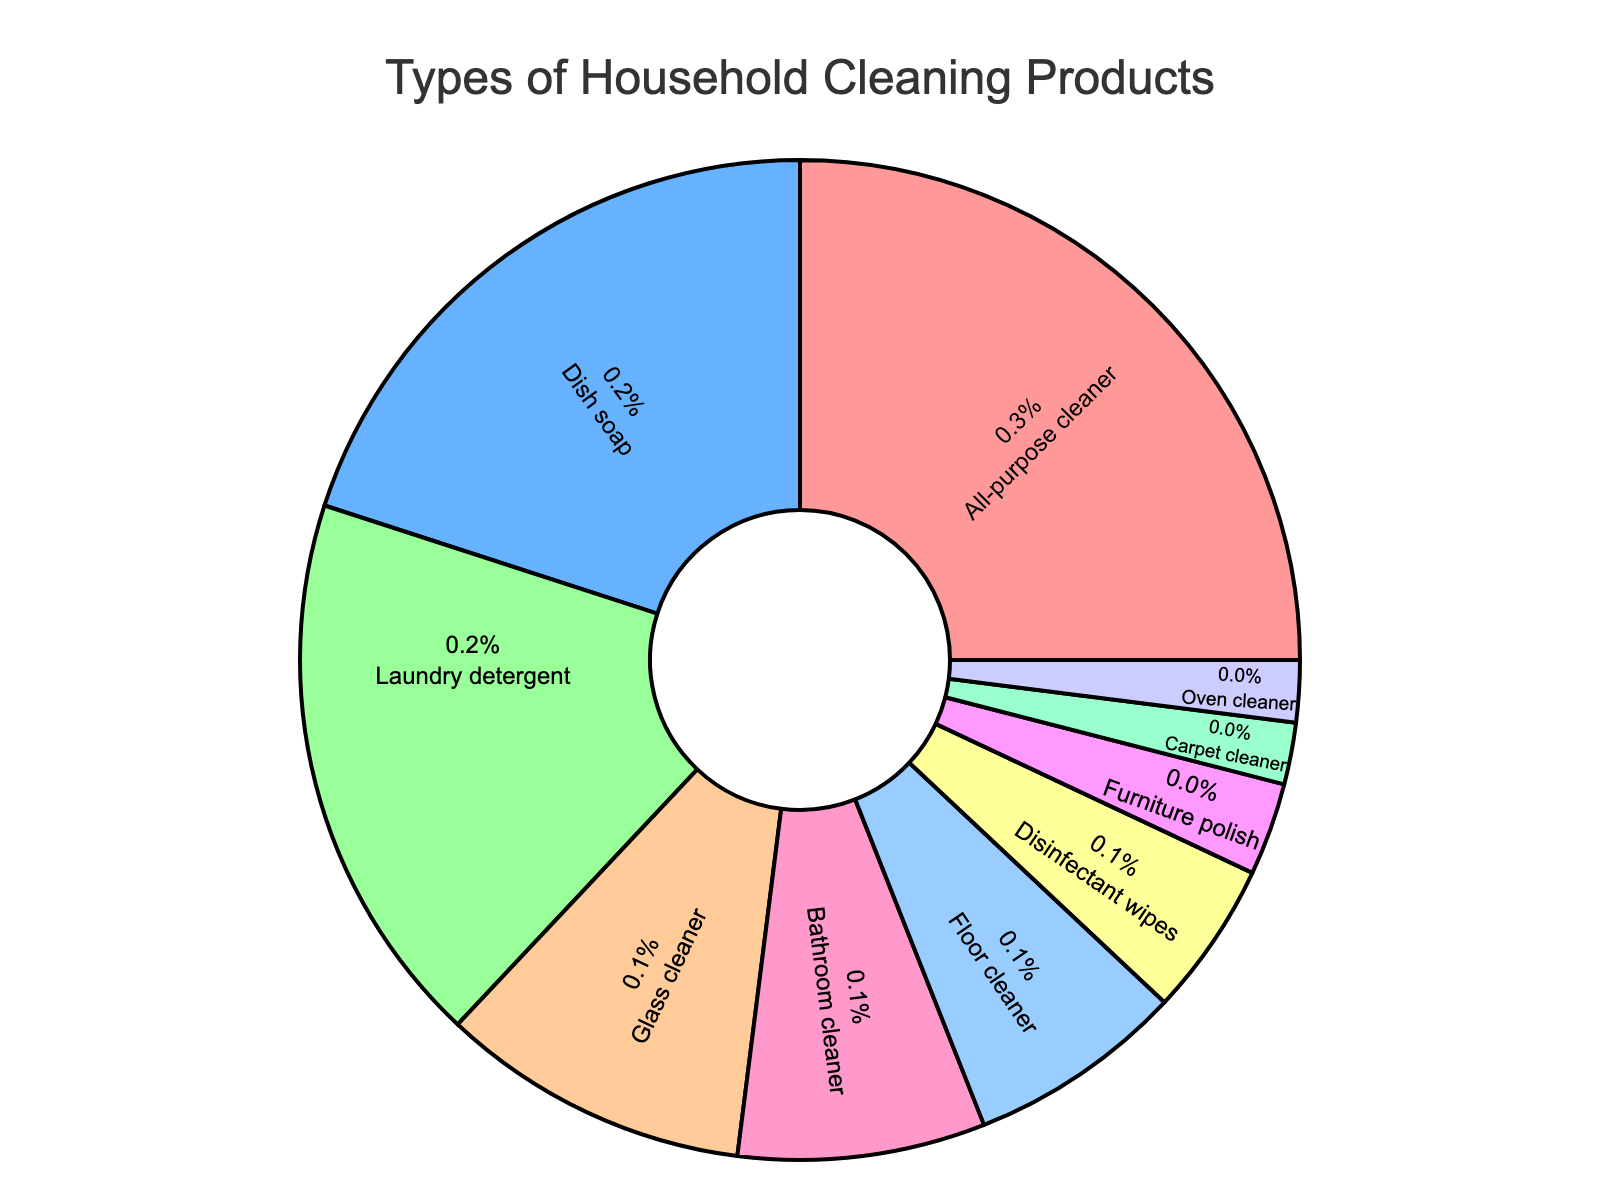What percentage of household cleaning products is allocated to dish soap and laundry detergent combined? Add the percentages of dish soap (20\%) and laundry detergent (18\%): 20 + 18 = 38
Answer: 38\% Which product is used more, disinfectant wipes or furniture polish? Compare the percentages: disinfectant wipes (5\%) and furniture polish (3\%). Since 5\% is greater than 3\%, disinfectant wipes are used more.
Answer: Disinfectant wipes Which product has the smallest share in the pie chart? The smallest percentage is 2\%, which is the share for both carpet cleaner and oven cleaner.
Answer: Carpet cleaner and oven cleaner What is the total percentage of cleaning products used for cleaning utensils (dish soap) and for cleaning clothes (laundry detergent)? Sum the percentages: dish soap (20\%) + laundry detergent (18\%) = 38
Answer: 38\% How does the usage percentage of all-purpose cleaner compare to that of bathroom cleaner? Compare the percentages: all-purpose cleaner (25\%) and bathroom cleaner (8\%). Since 25\% is greater than 8\%, all-purpose cleaner is used more.
Answer: All-purpose cleaner is used more Which color represents the segment for floor cleaner, and what is its percentage? The segment for floor cleaner is represented by a blue color and has a percentage of 7\%.
Answer: Blue, 7\% If the percentages are ranked from highest to lowest, what rank does glass cleaner hold? The percentages in descending order are: all-purpose cleaner (25\%), dish soap (20\%), laundry detergent (18\%), glass cleaner (10\%), bathroom cleaner (8\%), floor cleaner (7\%), disinfectant wipes (5\%), furniture polish (3\%), carpet cleaner (2\%), oven cleaner (2\%). Glass cleaner is at the 4th position.
Answer: 4th What is the difference in usage between the second-most and the least used cleaning products? The second-most used product is dish soap (20\%) and the least used products are carpet cleaner and oven cleaner (both 2\%). Difference: 20 - 2 = 18
Answer: 18\% If you grouped all specific surface cleaners (glass cleaner, bathroom cleaner, floor cleaner, furniture polish, carpet cleaner, oven cleaner) together, what percentage would they cover? Sum the specific surface cleaners' percentages: glass cleaner (10\%) + bathroom cleaner (8\%) + floor cleaner (7\%) + furniture polish (3\%) + carpet cleaner (2\%) + oven cleaner (2\%) = 32
Answer: 32\% What is the second least represented product in the chart? The least represented products are carpet cleaner and oven cleaner (2\%). The next one up is furniture polish (3\%).
Answer: Furniture polish 